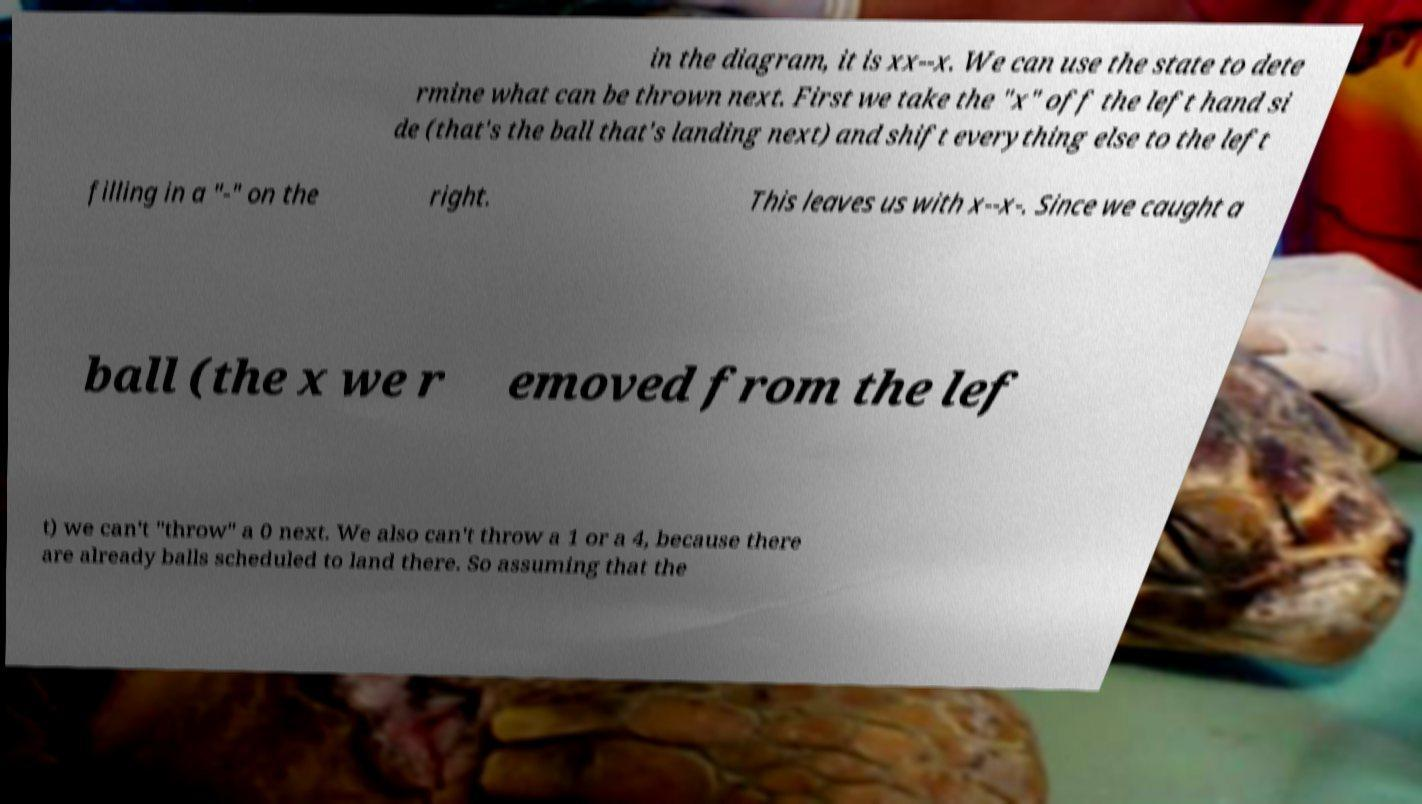For documentation purposes, I need the text within this image transcribed. Could you provide that? in the diagram, it is xx--x. We can use the state to dete rmine what can be thrown next. First we take the "x" off the left hand si de (that's the ball that's landing next) and shift everything else to the left filling in a "-" on the right. This leaves us with x--x-. Since we caught a ball (the x we r emoved from the lef t) we can't "throw" a 0 next. We also can't throw a 1 or a 4, because there are already balls scheduled to land there. So assuming that the 